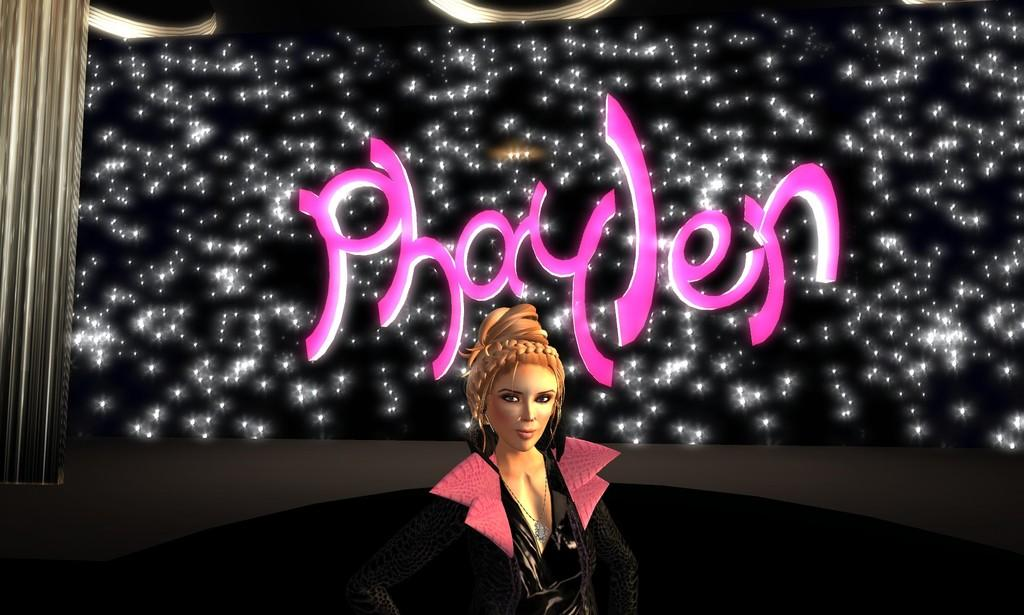Who is present in the image? There is a woman in the image. What else can be seen in the image besides the woman? There is text and stars visible in the image. What is on the left side of the image? There is a curtain on the left side of the image. How many bikes are parked behind the curtain in the image? There are no bikes present in the image, so it is not possible to determine how many there might be behind the curtain. 